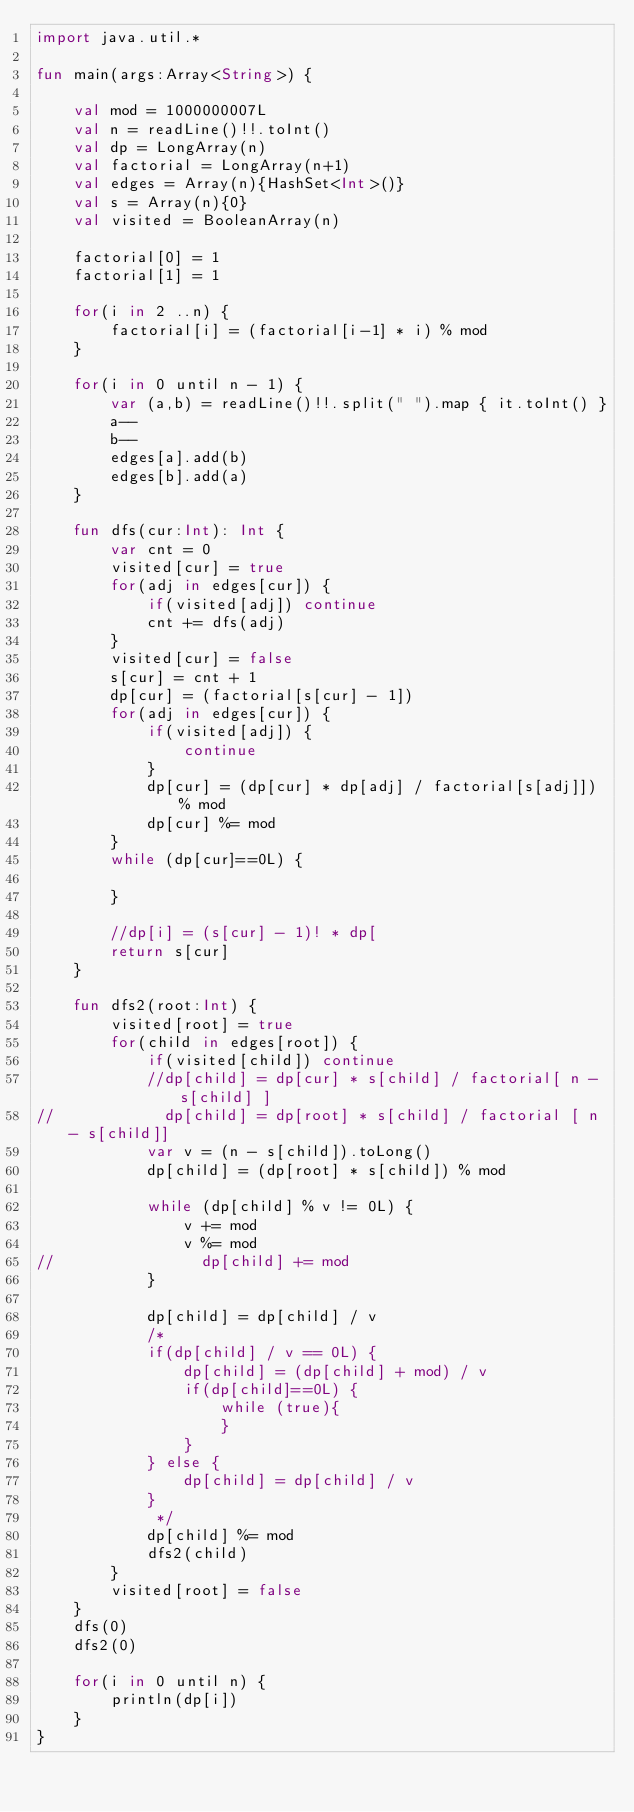Convert code to text. <code><loc_0><loc_0><loc_500><loc_500><_Kotlin_>import java.util.*

fun main(args:Array<String>) {

    val mod = 1000000007L
    val n = readLine()!!.toInt()
    val dp = LongArray(n)
    val factorial = LongArray(n+1)
    val edges = Array(n){HashSet<Int>()}
    val s = Array(n){0}
    val visited = BooleanArray(n)

    factorial[0] = 1
    factorial[1] = 1

    for(i in 2 ..n) {
        factorial[i] = (factorial[i-1] * i) % mod
    }

    for(i in 0 until n - 1) {
        var (a,b) = readLine()!!.split(" ").map { it.toInt() }
        a--
        b--
        edges[a].add(b)
        edges[b].add(a)
    }

    fun dfs(cur:Int): Int {
        var cnt = 0
        visited[cur] = true
        for(adj in edges[cur]) {
            if(visited[adj]) continue
            cnt += dfs(adj)
        }
        visited[cur] = false
        s[cur] = cnt + 1
        dp[cur] = (factorial[s[cur] - 1])
        for(adj in edges[cur]) {
            if(visited[adj]) {
                continue
            }
            dp[cur] = (dp[cur] * dp[adj] / factorial[s[adj]]) % mod
            dp[cur] %= mod
        }
        while (dp[cur]==0L) {

        }

        //dp[i] = (s[cur] - 1)! * dp[
        return s[cur]
    }

    fun dfs2(root:Int) {
        visited[root] = true
        for(child in edges[root]) {
            if(visited[child]) continue
            //dp[child] = dp[cur] * s[child] / factorial[ n - s[child] ]
//            dp[child] = dp[root] * s[child] / factorial [ n - s[child]]
            var v = (n - s[child]).toLong()
            dp[child] = (dp[root] * s[child]) % mod

            while (dp[child] % v != 0L) {
                v += mod
                v %= mod
//                dp[child] += mod
            }

            dp[child] = dp[child] / v
            /*
            if(dp[child] / v == 0L) {
                dp[child] = (dp[child] + mod) / v
                if(dp[child]==0L) {
                    while (true){
                    }
                }
            } else {
                dp[child] = dp[child] / v
            }
             */
            dp[child] %= mod
            dfs2(child)
        }
        visited[root] = false
    }
    dfs(0)
    dfs2(0)

    for(i in 0 until n) {
        println(dp[i])
    }
}</code> 